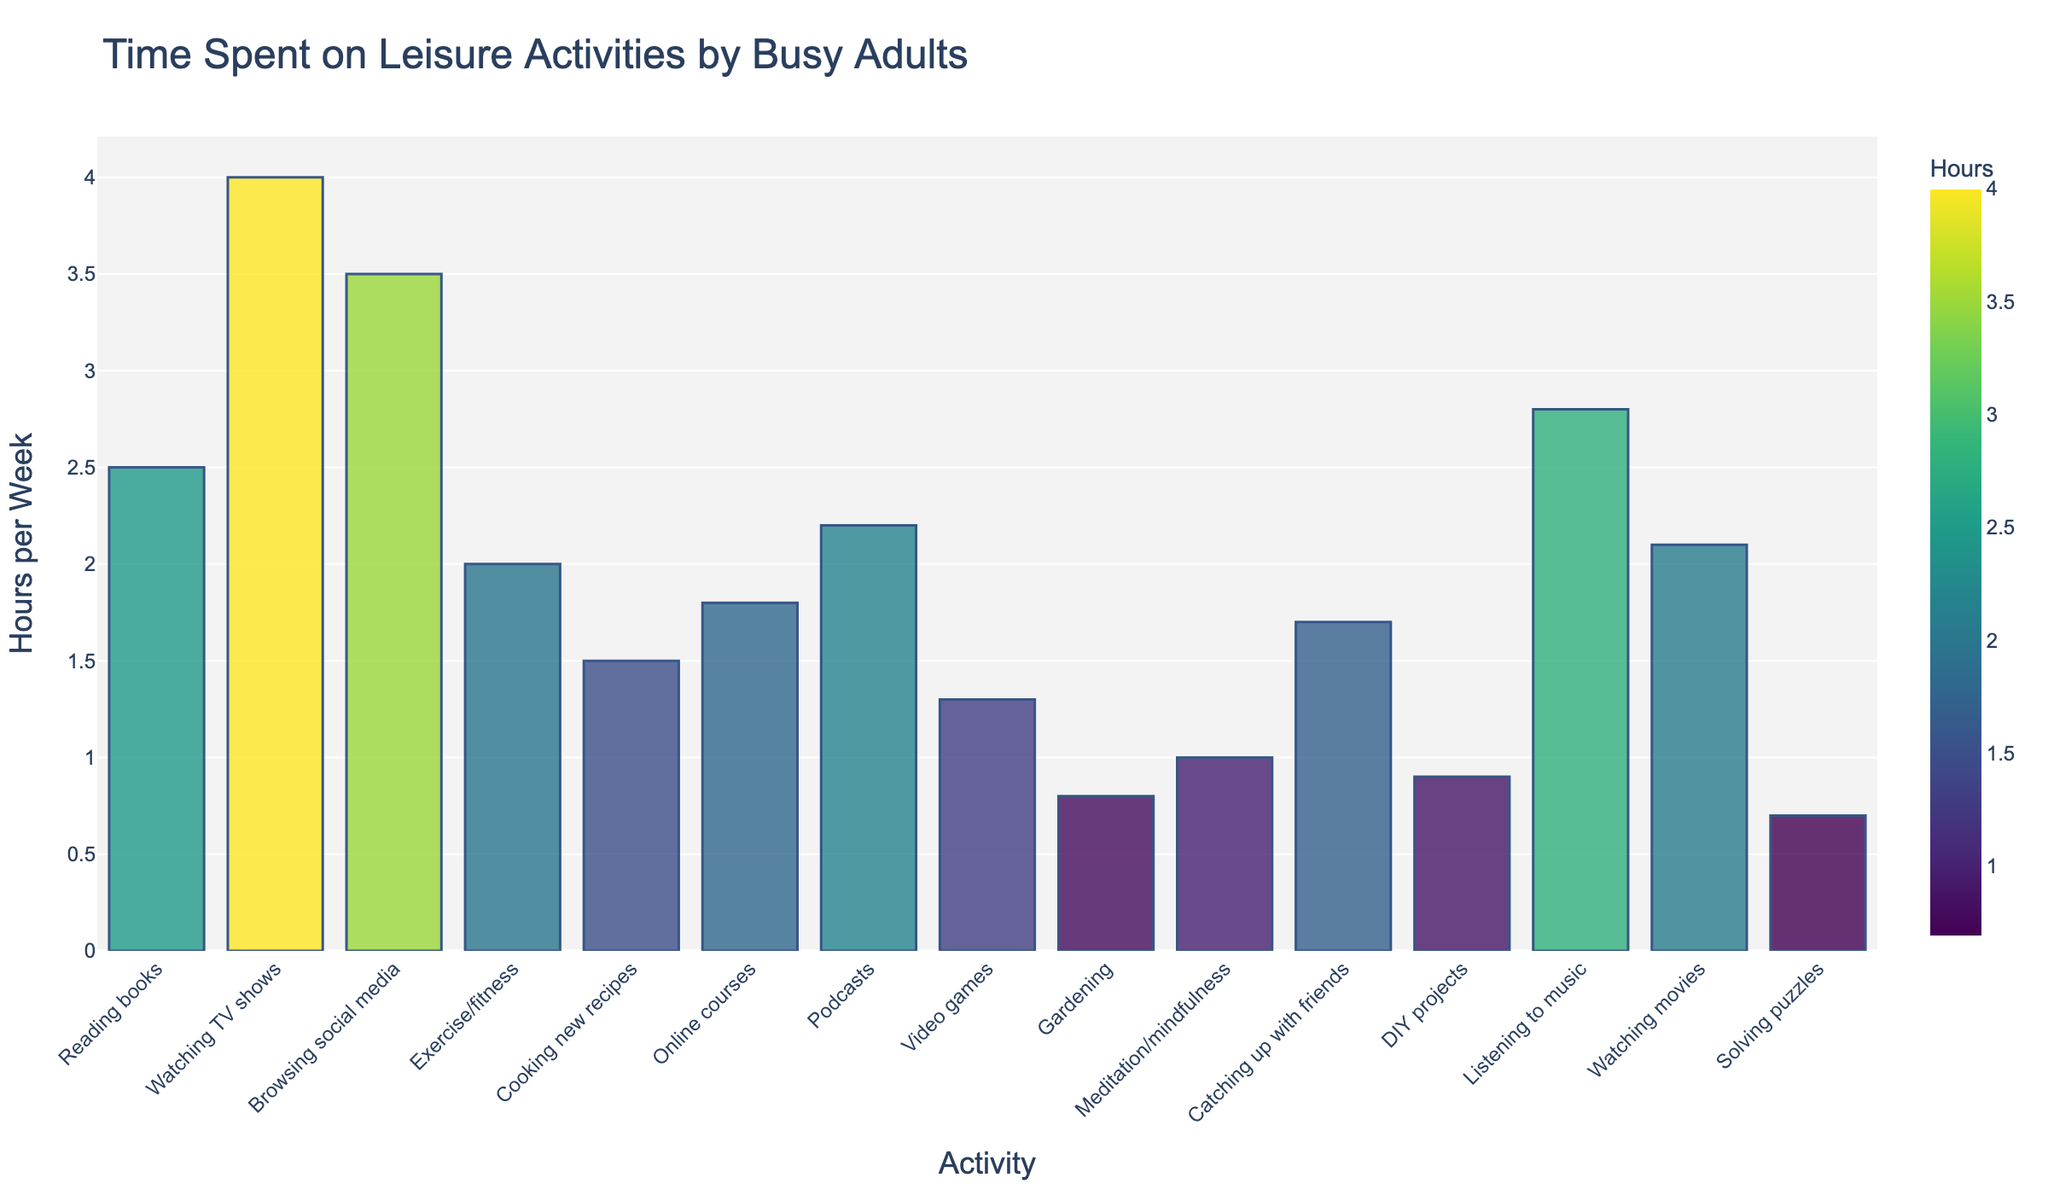what is the most time-consuming leisure activity? Look at the bars on the chart and identify the bar with the greatest height, which indicates the highest value in hours per week.
Answer: Watching TV shows how much more time is spent on reading books compared to solving puzzles? Locate the bars for "Reading books" and "Solving puzzles." The difference is calculated by subtracting the value of the latter from the former: 2.5 (Reading books) - 0.7 (Solving puzzles).
Answer: 1.8 hours what is the total time spent on online activities (Browsing social media and Online courses)? Add the hours from "Browsing social media" and "Online courses": 3.5 + 1.8.
Answer: 5.3 hours which activity occupies more time, listening to music or watching movies? Compare the heights of the bars for "Listening to music" and "Watching movies." The taller bar indicates more hours spent.
Answer: Listening to music is more time spent on exercise/fitness or meditation/mindfulness? Compare the heights of the bars for "Exercise/fitness" and "Meditation/mindfulness." The taller bar represents more hours spent.
Answer: Exercise/fitness how much time in total is spent on activities related to self-improvement (Exercise/fitness, Meditation/mindfulness, Online courses)? Sum the hours from these activities: 2.0 (Exercise/fitness) + 1.0 (Meditation/mindfulness) + 1.8 (Online courses).
Answer: 4.8 hours what is the average time spent on leisure activities across all categories? Sum the hours of all activities and divide by the total number of activities: (2.5 + 4.0 + 3.5 + 2.0 + 1.5 + 1.8 + 2.2 + 1.3 + 0.8 + 1.0 + 1.7 + 0.9 + 2.8 + 2.1 + 0.7) / 15.
Answer: 2.0 hours which two activities have the closest amount of time spent on them? Find the bars whose heights are the closest in value. The two closest activities appear to be "Online courses" (1.8) and "Catching up with friends" (1.7).
Answer: Online courses and Catching up with friends what is the proportion of time spent on cooking new recipes relative to the total time spent on all activities? Calculate the ratio by dividing the hours spent on "Cooking new recipes" by the total hours: 1.5 / (sum of all hours).
Answer: 0.05 (or 5%) which activity has a visual attribute of having one of the shortest bars on the chart? Identify one of the shortest bars in the chart by comparing their heights visually, which corresponds to the activity with the least amount of time spent.
Answer: Solving puzzles 